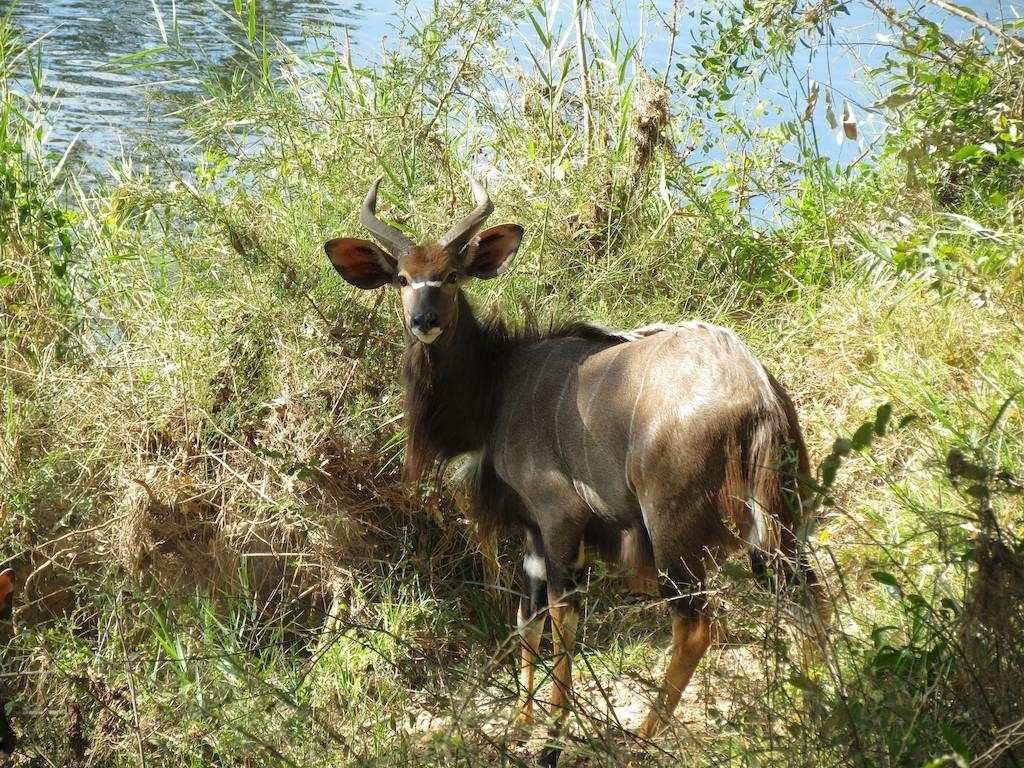What type of animal is in the image? The type of animal cannot be determined from the provided facts. Where is the animal located in the image? The animal is standing on the grass in the image. What can be seen in the background of the image? There is a river visible in the background of the image. What type of flower is the woman holding in the image? There is no woman or flower present in the image. 